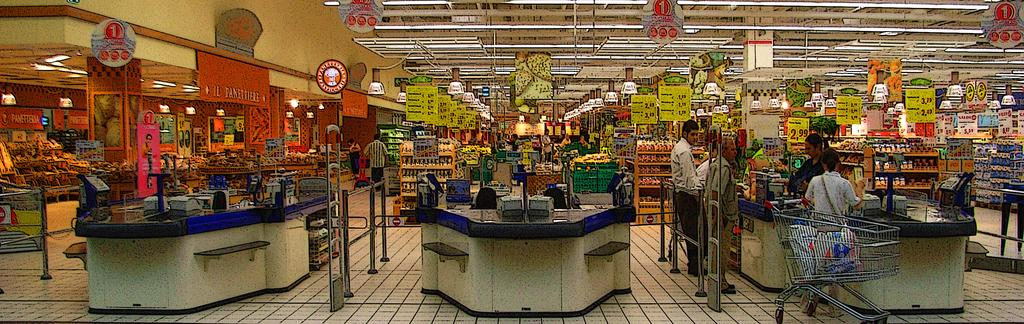<image>
Create a compact narrative representing the image presented. Supermarket signs display a number of different prices, including the figure $2.99. 